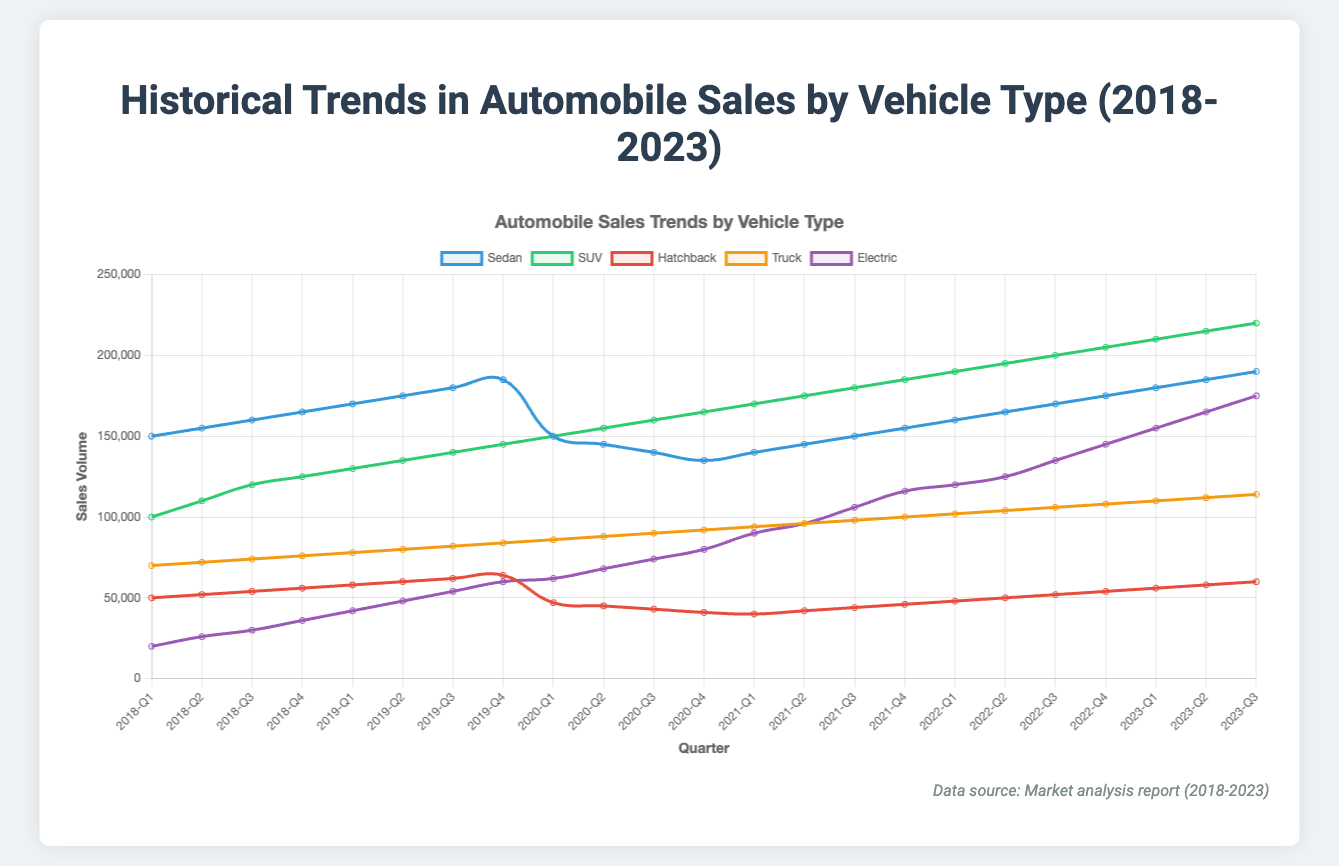What's the overall trend in SUV sales from 2018 to 2023? To determine the trend in SUV sales, observe the line representing SUVs. Starting at 100,000 in 2018-Q1, it consistently climbs until 220,000 in 2023-Q3, indicating a steady upward trend.
Answer: An upward trend Which vehicle type experienced the highest sales growth from 2018 to 2023? To find the highest sales growth, compare the starting and ending values for each vehicle type from 2018-Q1 to 2023-Q3. Electric vehicles grew from 20,000 to 175,000, which is the largest increase compared to others.
Answer: Electric How did sedan sales change during 2020? Observe the sedan sales data for 2020. Sales started at 150,000 in 2020-Q1, then decreased to 145,000, 140,000, and finally 135,000 by the end of 2020. This indicates a decline during this period.
Answer: They declined Between sedans and SUVs, which type had higher sales in 2022-Q2? Compare the sales values for sedans and SUVs in 2022-Q2. Sedan sales were 165,000, while SUV sales were 195,000 in 2022-Q2. Thus, SUVs had higher sales.
Answer: SUVs What was the sales volume for Electric vehicles in 2021-Q4? Look at the data point for Electric vehicles in 2021-Q4. The sales volume for this period is 116,000.
Answer: 116,000 By how much did truck sales increase from 2018-Q1 to 2023-Q3? To determine the sales increase, subtract the starting value in 2018-Q1 (70,000) from the ending value in 2023-Q3 (114,000). The increase is 114,000 - 70,000.
Answer: 44,000 Which vehicle type had the lowest sales in 2020-Q3? Check the sales data for all vehicle types in 2020-Q3. Hatchbacks had the lowest sales at 43,000 in 2020-Q3.
Answer: Hatchback In which quarter of 2022 did sedan sales first reach 170,000? Examine the sedan sales data throughout 2022 quarters. Sales first reached 170,000 in 2022-Q3.
Answer: 2022-Q3 What is the overall trend in hatchback sales from 2018 to 2023? Hatchback sales show a mixed trend: an increase from 50,000 to 64,000 until 2019-Q4, a drop to 41,000 by the end of 2020, and a recovery to 60,000 by 2023-Q3.
Answer: Mixed trend with initial rise, drop, and recovery Compare the trendlines for trucks and electric vehicles. Which one exhibits a more rapid increase? Assess the slopes of both trendlines. Electric vehicles rise from 20,000 to 175,000, while trucks rise from 70,000 to 114,000 from 2018-Q1 to 2023-Q3. The steeper slope for Electric indicates more rapid growth.
Answer: Electric vehicles 